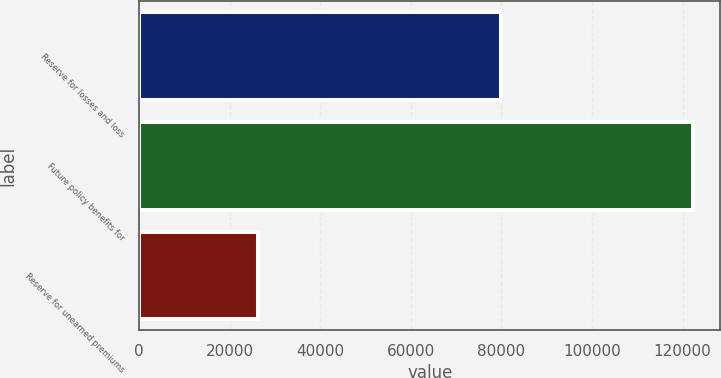Convert chart. <chart><loc_0><loc_0><loc_500><loc_500><bar_chart><fcel>Reserve for losses and loss<fcel>Future policy benefits for<fcel>Reserve for unearned premiums<nl><fcel>79999<fcel>122230<fcel>26271<nl></chart> 